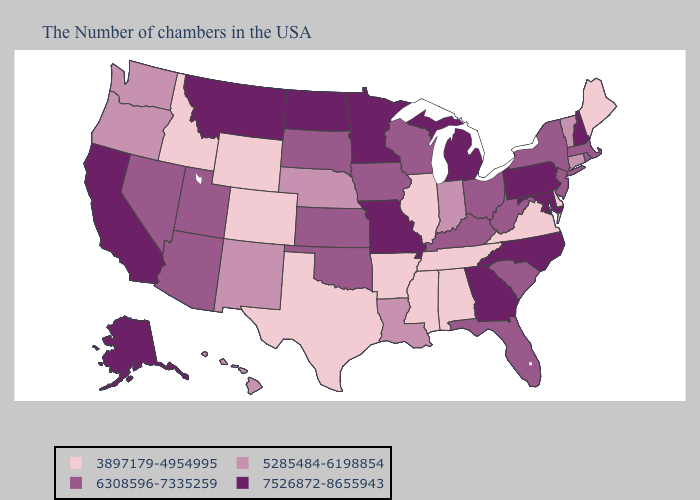What is the lowest value in the USA?
Quick response, please. 3897179-4954995. Does Delaware have the lowest value in the USA?
Give a very brief answer. Yes. Does South Dakota have a lower value than New Jersey?
Answer briefly. No. Does South Dakota have a lower value than Maine?
Give a very brief answer. No. Among the states that border Oklahoma , which have the lowest value?
Concise answer only. Arkansas, Texas, Colorado. Does the first symbol in the legend represent the smallest category?
Short answer required. Yes. Does Ohio have the lowest value in the USA?
Quick response, please. No. Which states have the highest value in the USA?
Quick response, please. New Hampshire, Maryland, Pennsylvania, North Carolina, Georgia, Michigan, Missouri, Minnesota, North Dakota, Montana, California, Alaska. Name the states that have a value in the range 6308596-7335259?
Give a very brief answer. Massachusetts, Rhode Island, New York, New Jersey, South Carolina, West Virginia, Ohio, Florida, Kentucky, Wisconsin, Iowa, Kansas, Oklahoma, South Dakota, Utah, Arizona, Nevada. What is the value of Alabama?
Short answer required. 3897179-4954995. How many symbols are there in the legend?
Give a very brief answer. 4. What is the value of Louisiana?
Give a very brief answer. 5285484-6198854. What is the value of Kansas?
Keep it brief. 6308596-7335259. What is the highest value in states that border Wyoming?
Give a very brief answer. 7526872-8655943. 